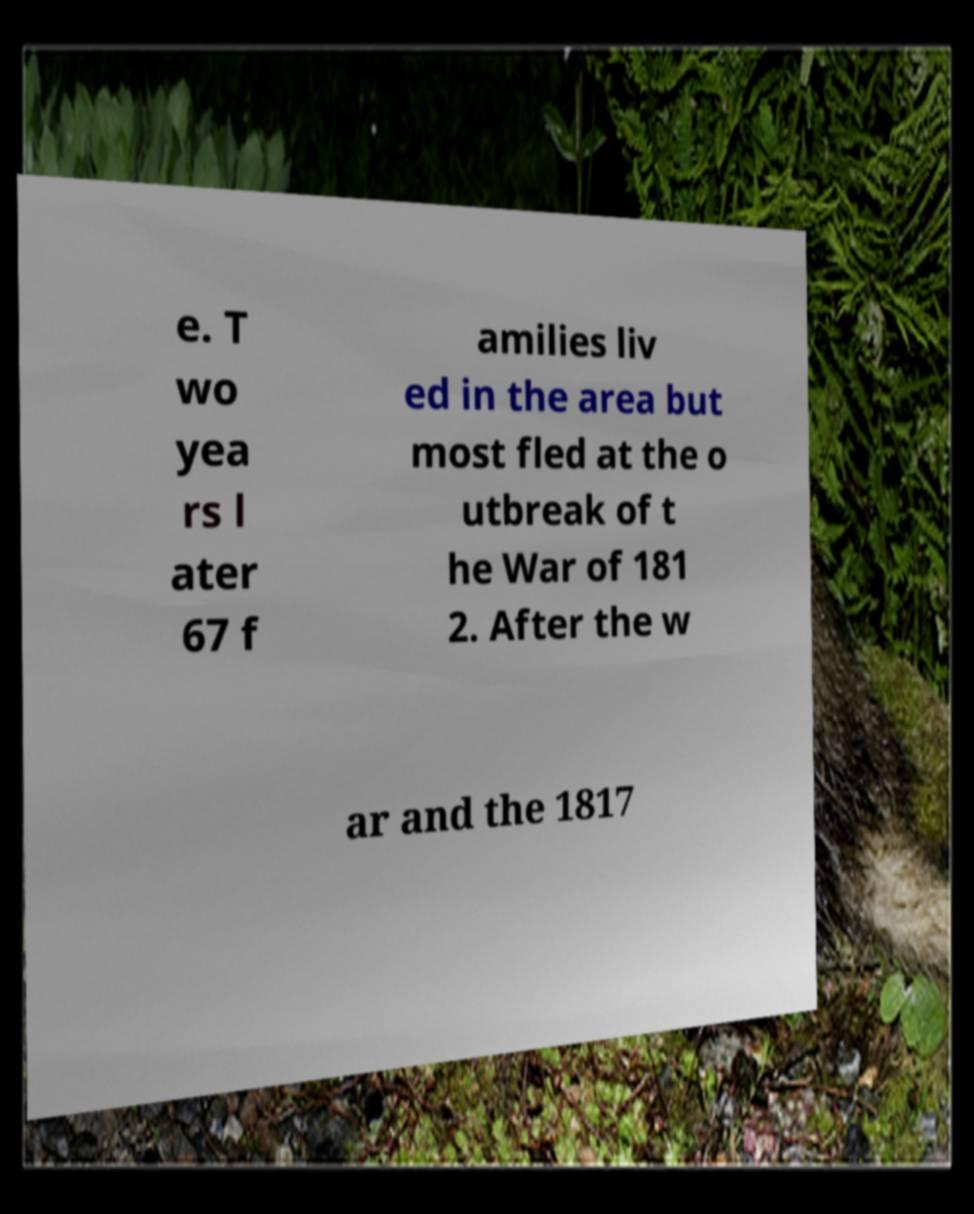Can you read and provide the text displayed in the image?This photo seems to have some interesting text. Can you extract and type it out for me? e. T wo yea rs l ater 67 f amilies liv ed in the area but most fled at the o utbreak of t he War of 181 2. After the w ar and the 1817 